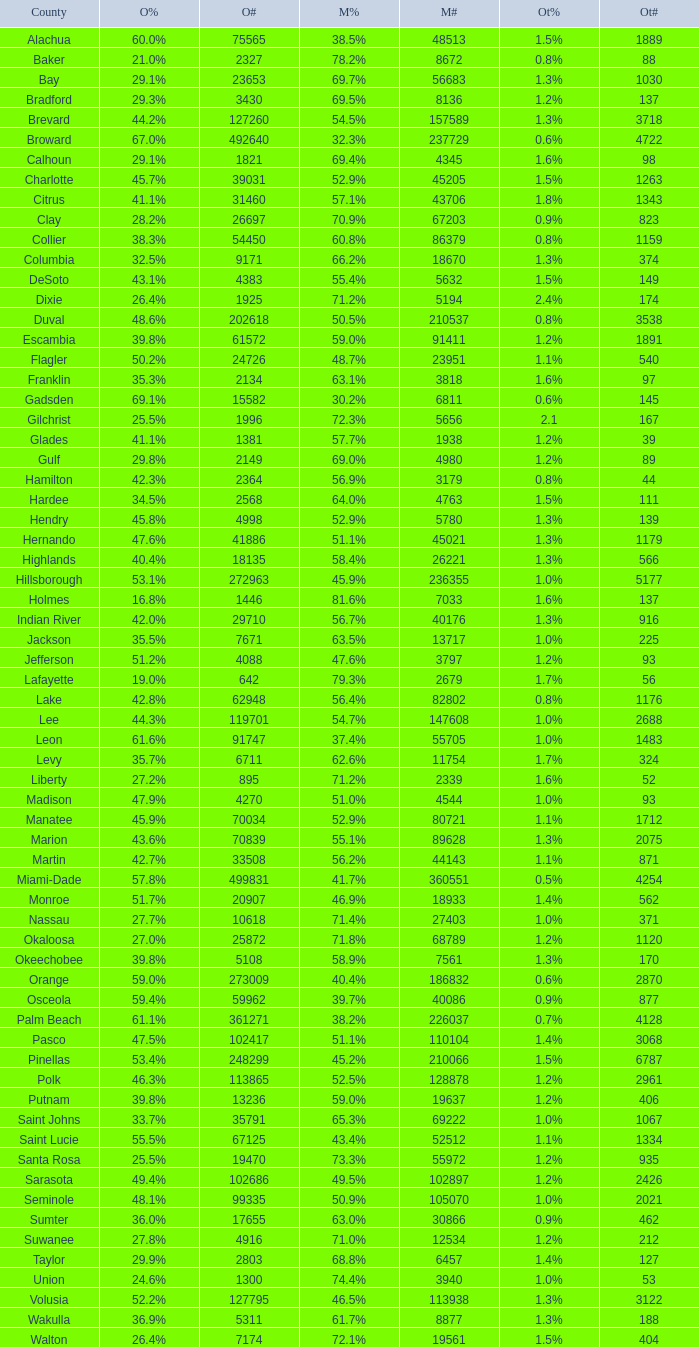What percent was the other's vote when mccain had 5 1.3%. 